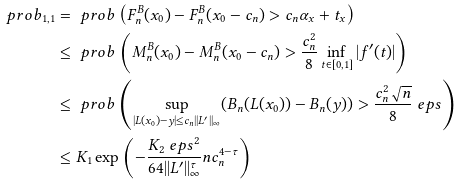Convert formula to latex. <formula><loc_0><loc_0><loc_500><loc_500>\ p r o b _ { 1 , 1 } & = \ p r o b \left ( F _ { n } ^ { B } ( x _ { 0 } ) - F _ { n } ^ { B } ( x _ { 0 } - c _ { n } ) > c _ { n } \alpha _ { x } + t _ { x } \right ) \\ & \leq \ p r o b \left ( M _ { n } ^ { B } ( x _ { 0 } ) - M _ { n } ^ { B } ( x _ { 0 } - c _ { n } ) > \frac { c _ { n } ^ { 2 } } { 8 } \inf _ { t \in [ 0 , 1 ] } | f ^ { \prime } ( t ) | \right ) \\ & \leq \ p r o b \left ( \sup _ { | L ( x _ { 0 } ) - y | \leq c _ { n } | | L ^ { \prime } | | _ { \infty } } ( B _ { n } ( L ( x _ { 0 } ) ) - B _ { n } ( y ) ) > \frac { c _ { n } ^ { 2 } \sqrt { n } } { 8 } \ e p s \right ) \\ & \leq K _ { 1 } \exp \left ( - \frac { K _ { 2 } \ e p s ^ { 2 } } { 6 4 | | L ^ { \prime } | | _ { \infty } ^ { \tau } } n c _ { n } ^ { 4 - \tau } \right )</formula> 